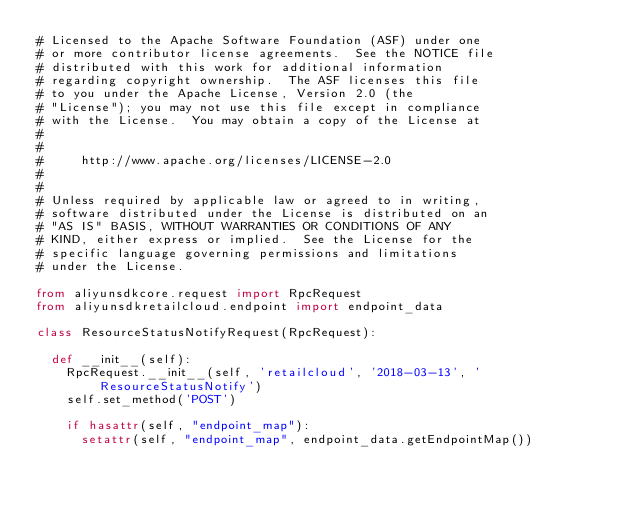<code> <loc_0><loc_0><loc_500><loc_500><_Python_># Licensed to the Apache Software Foundation (ASF) under one
# or more contributor license agreements.  See the NOTICE file
# distributed with this work for additional information
# regarding copyright ownership.  The ASF licenses this file
# to you under the Apache License, Version 2.0 (the
# "License"); you may not use this file except in compliance
# with the License.  You may obtain a copy of the License at
#
#
#     http://www.apache.org/licenses/LICENSE-2.0
#
#
# Unless required by applicable law or agreed to in writing,
# software distributed under the License is distributed on an
# "AS IS" BASIS, WITHOUT WARRANTIES OR CONDITIONS OF ANY
# KIND, either express or implied.  See the License for the
# specific language governing permissions and limitations
# under the License.

from aliyunsdkcore.request import RpcRequest
from aliyunsdkretailcloud.endpoint import endpoint_data

class ResourceStatusNotifyRequest(RpcRequest):

	def __init__(self):
		RpcRequest.__init__(self, 'retailcloud', '2018-03-13', 'ResourceStatusNotify')
		self.set_method('POST')

		if hasattr(self, "endpoint_map"):
			setattr(self, "endpoint_map", endpoint_data.getEndpointMap())</code> 